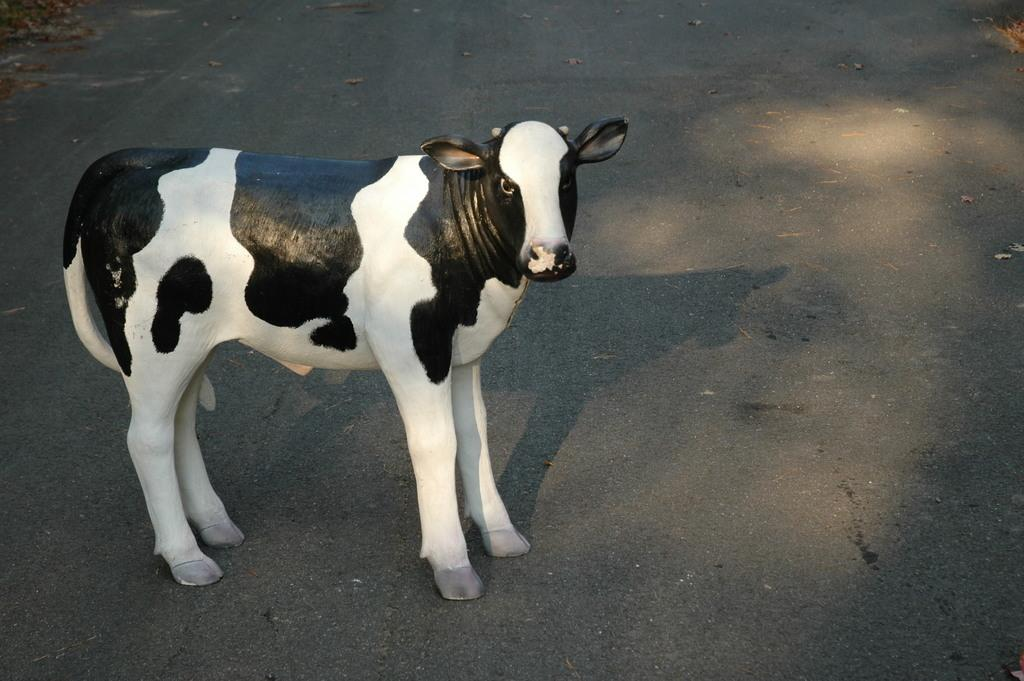What animal is present in the image? There is a cow in the image. Where is the cow located in the image? The cow is standing on the road. What is the chance of the cow winning a beauty contest in the image? There is no indication of a beauty contest or any judging of the cow's appearance in the image. 